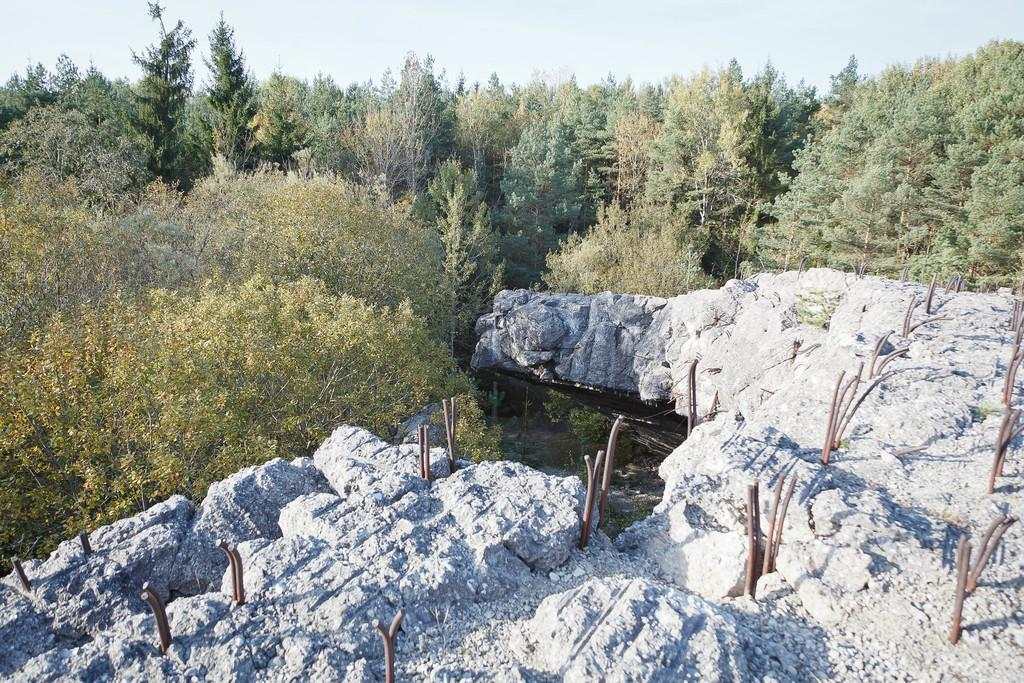What can be seen in the sky in the image? The sky is visible in the image. What type of vegetation is present in the image? There are trees in the image. What body of water is in the image? There is a pond in the image. What type of natural formation is present in the image? Rocks are present in the image. What man-made structures can be seen in the image? Poles are visible in the image. What type of sea creature can be seen swimming in the pond in the image? There is no sea creature present in the image, as the body of water is a pond, not a sea. 